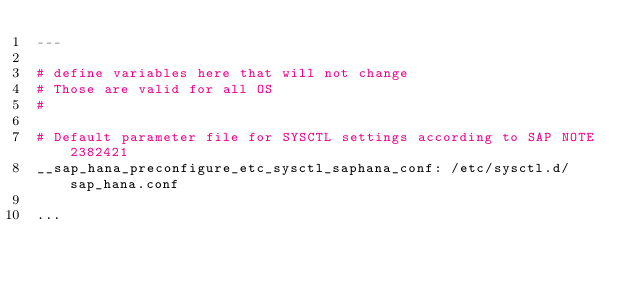<code> <loc_0><loc_0><loc_500><loc_500><_YAML_>---

# define variables here that will not change
# Those are valid for all OS
#

# Default parameter file for SYSCTL settings according to SAP NOTE 2382421
__sap_hana_preconfigure_etc_sysctl_saphana_conf: /etc/sysctl.d/sap_hana.conf

...
</code> 